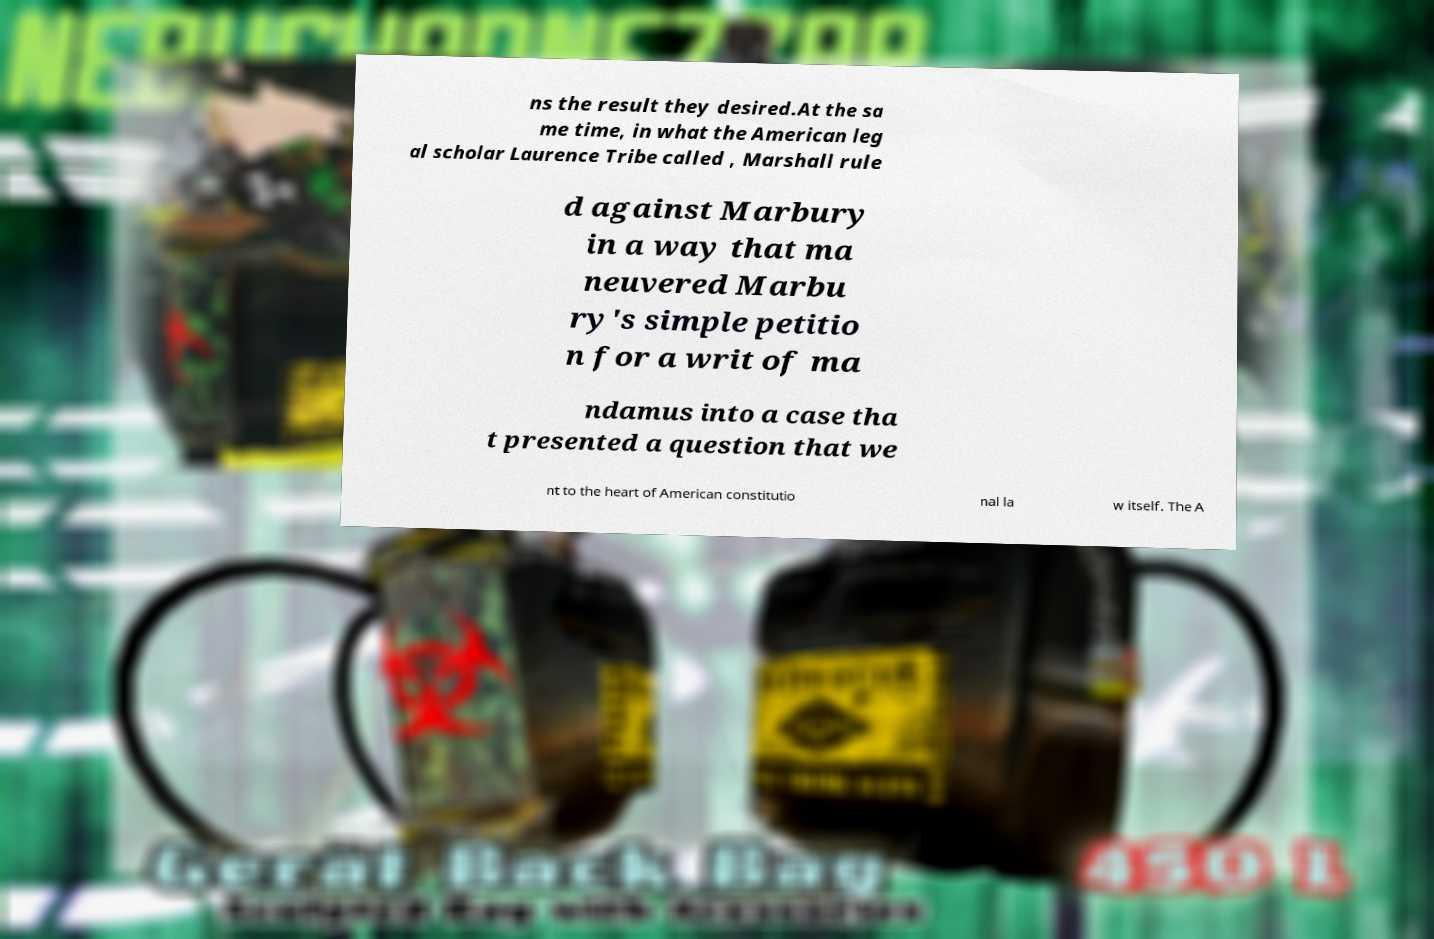There's text embedded in this image that I need extracted. Can you transcribe it verbatim? ns the result they desired.At the sa me time, in what the American leg al scholar Laurence Tribe called , Marshall rule d against Marbury in a way that ma neuvered Marbu ry's simple petitio n for a writ of ma ndamus into a case tha t presented a question that we nt to the heart of American constitutio nal la w itself. The A 